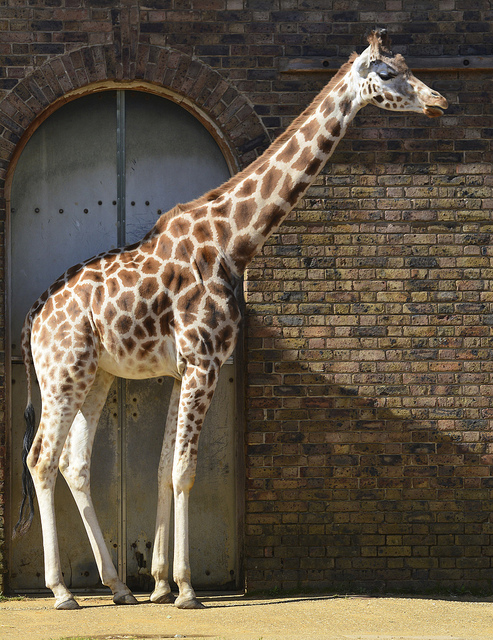<image>In what way does the giraffe and the wall match? It is ambiguous to say in what way the giraffe and the wall match. Some suggest it might be due to similar colors or brown spots. In what way does the giraffe and the wall match? I don't know how the giraffe and the wall match. It can be their brown spots or similar colors. 